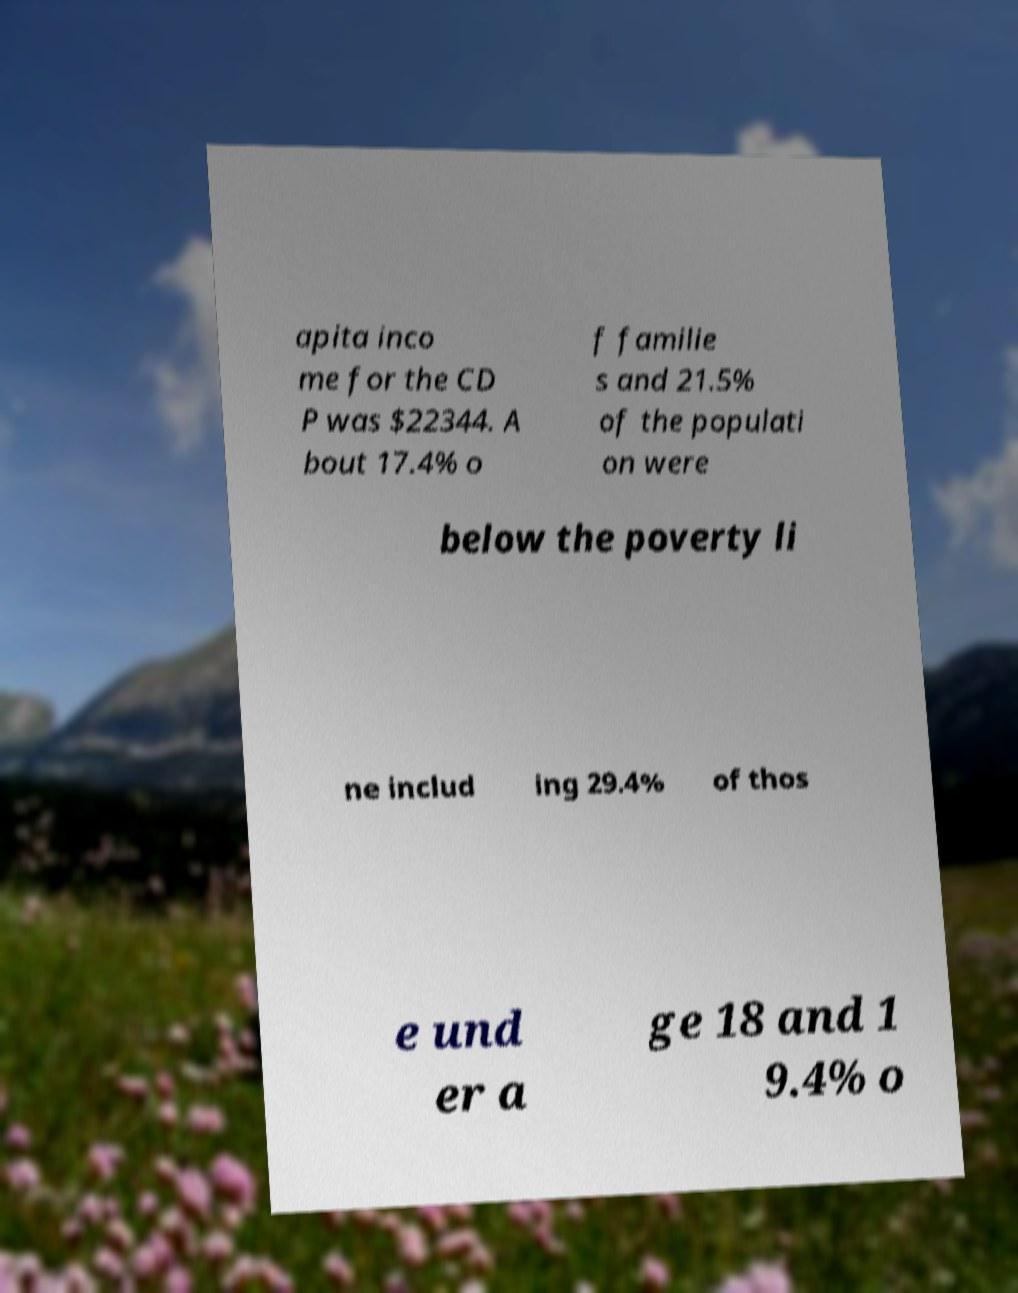Please read and relay the text visible in this image. What does it say? apita inco me for the CD P was $22344. A bout 17.4% o f familie s and 21.5% of the populati on were below the poverty li ne includ ing 29.4% of thos e und er a ge 18 and 1 9.4% o 